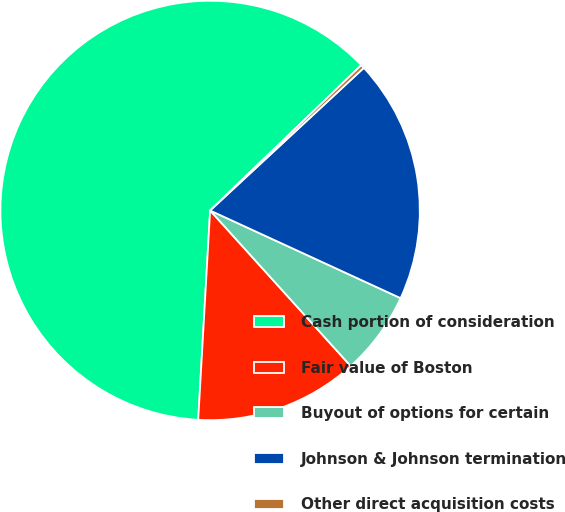Convert chart. <chart><loc_0><loc_0><loc_500><loc_500><pie_chart><fcel>Cash portion of consideration<fcel>Fair value of Boston<fcel>Buyout of options for certain<fcel>Johnson & Johnson termination<fcel>Other direct acquisition costs<nl><fcel>61.91%<fcel>12.6%<fcel>6.44%<fcel>18.77%<fcel>0.28%<nl></chart> 